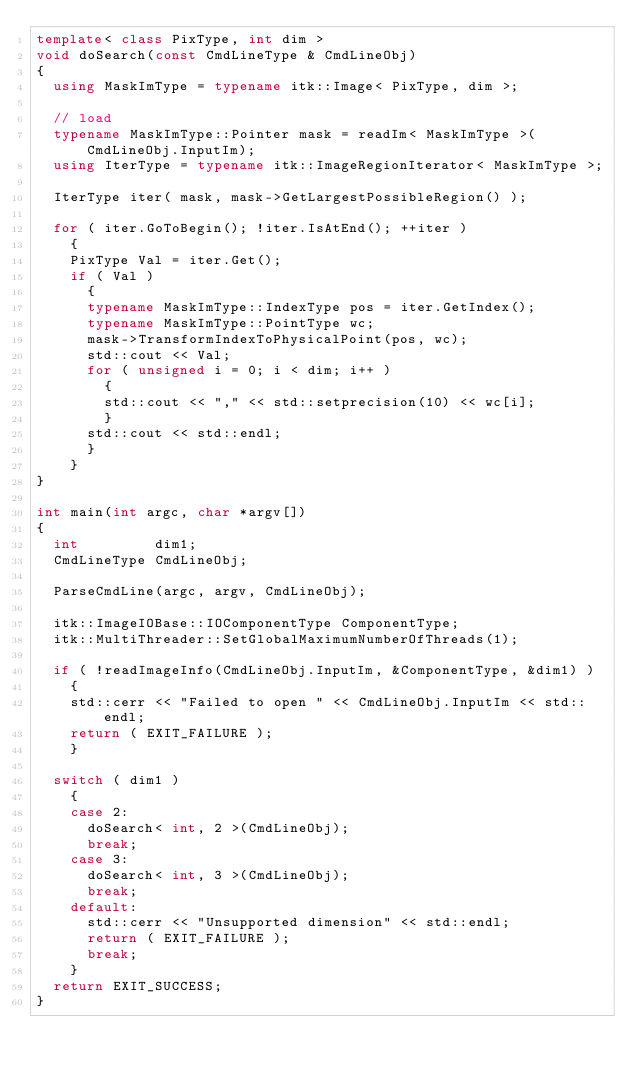<code> <loc_0><loc_0><loc_500><loc_500><_C++_>template< class PixType, int dim >
void doSearch(const CmdLineType & CmdLineObj)
{
  using MaskImType = typename itk::Image< PixType, dim >;

  // load
  typename MaskImType::Pointer mask = readIm< MaskImType >(CmdLineObj.InputIm);
  using IterType = typename itk::ImageRegionIterator< MaskImType >;

  IterType iter( mask, mask->GetLargestPossibleRegion() );

  for ( iter.GoToBegin(); !iter.IsAtEnd(); ++iter )
    {
    PixType Val = iter.Get();
    if ( Val )
      {
      typename MaskImType::IndexType pos = iter.GetIndex();
      typename MaskImType::PointType wc;
      mask->TransformIndexToPhysicalPoint(pos, wc);
      std::cout << Val;
      for ( unsigned i = 0; i < dim; i++ )
        {
        std::cout << "," << std::setprecision(10) << wc[i];
        }
      std::cout << std::endl;
      }
    }
}

int main(int argc, char *argv[])
{
  int         dim1;
  CmdLineType CmdLineObj;

  ParseCmdLine(argc, argv, CmdLineObj);

  itk::ImageIOBase::IOComponentType ComponentType;
  itk::MultiThreader::SetGlobalMaximumNumberOfThreads(1);

  if ( !readImageInfo(CmdLineObj.InputIm, &ComponentType, &dim1) )
    {
    std::cerr << "Failed to open " << CmdLineObj.InputIm << std::endl;
    return ( EXIT_FAILURE );
    }

  switch ( dim1 )
    {
    case 2:
      doSearch< int, 2 >(CmdLineObj);
      break;
    case 3:
      doSearch< int, 3 >(CmdLineObj);
      break;
    default:
      std::cerr << "Unsupported dimension" << std::endl;
      return ( EXIT_FAILURE );
      break;
    }
  return EXIT_SUCCESS;
}
</code> 